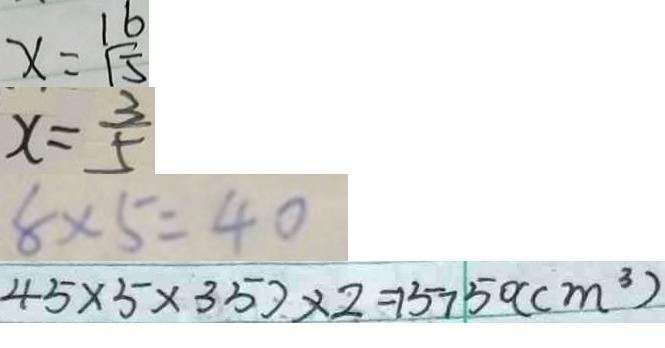<formula> <loc_0><loc_0><loc_500><loc_500>x = \frac { 1 6 } { 1 5 } 
 x = \frac { 3 } { 5 } 
 8 \times 5 = 4 0 
 4 5 \times 5 \times 3 5 ) \times 2 = 1 5 7 5 0 ( c m ^ { 3 } )</formula> 